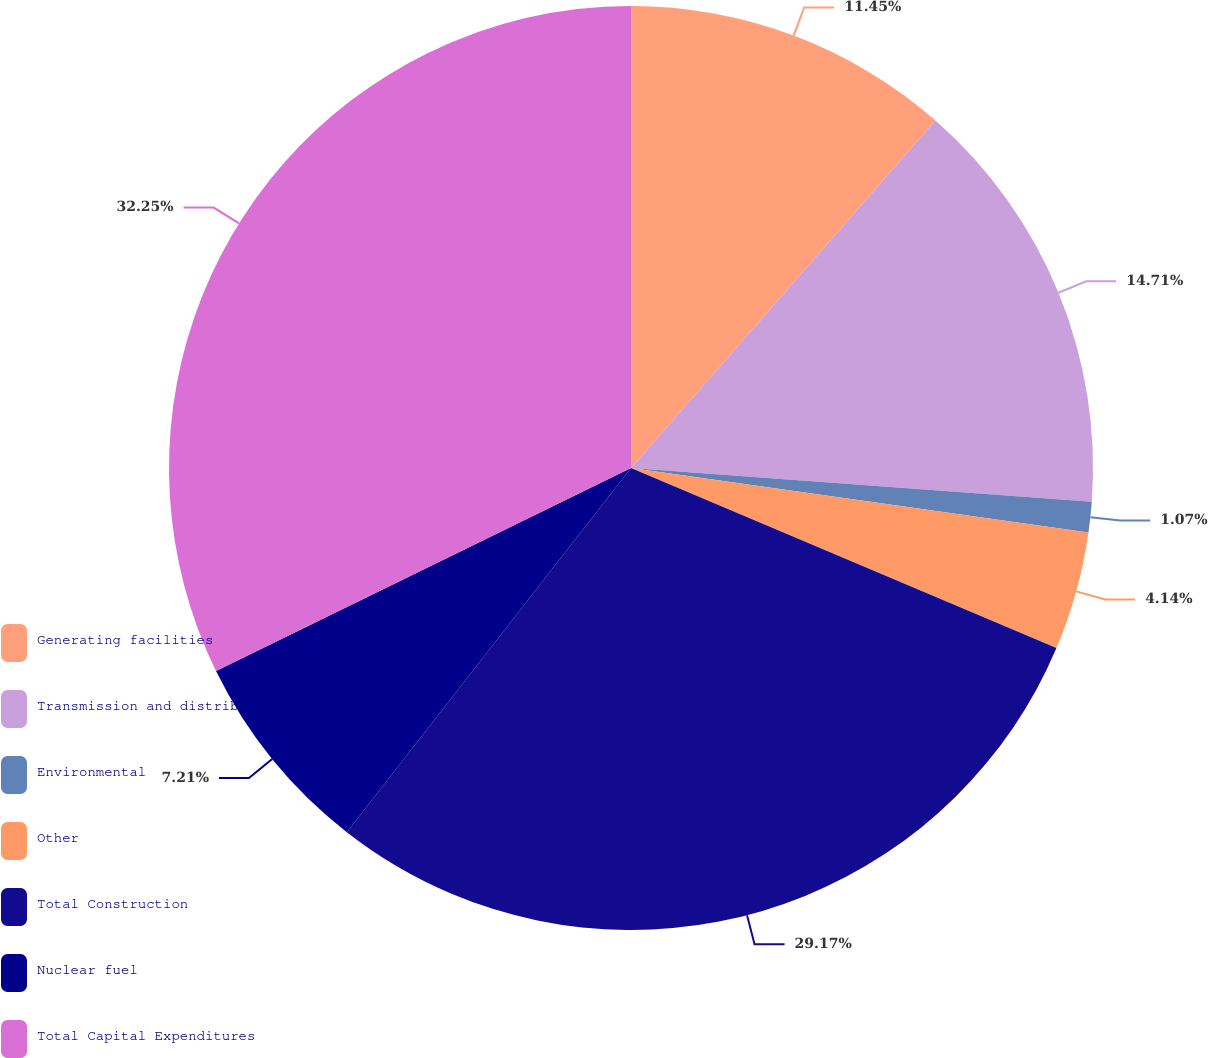Convert chart. <chart><loc_0><loc_0><loc_500><loc_500><pie_chart><fcel>Generating facilities<fcel>Transmission and distribution<fcel>Environmental<fcel>Other<fcel>Total Construction<fcel>Nuclear fuel<fcel>Total Capital Expenditures<nl><fcel>11.45%<fcel>14.71%<fcel>1.07%<fcel>4.14%<fcel>29.17%<fcel>7.21%<fcel>32.24%<nl></chart> 